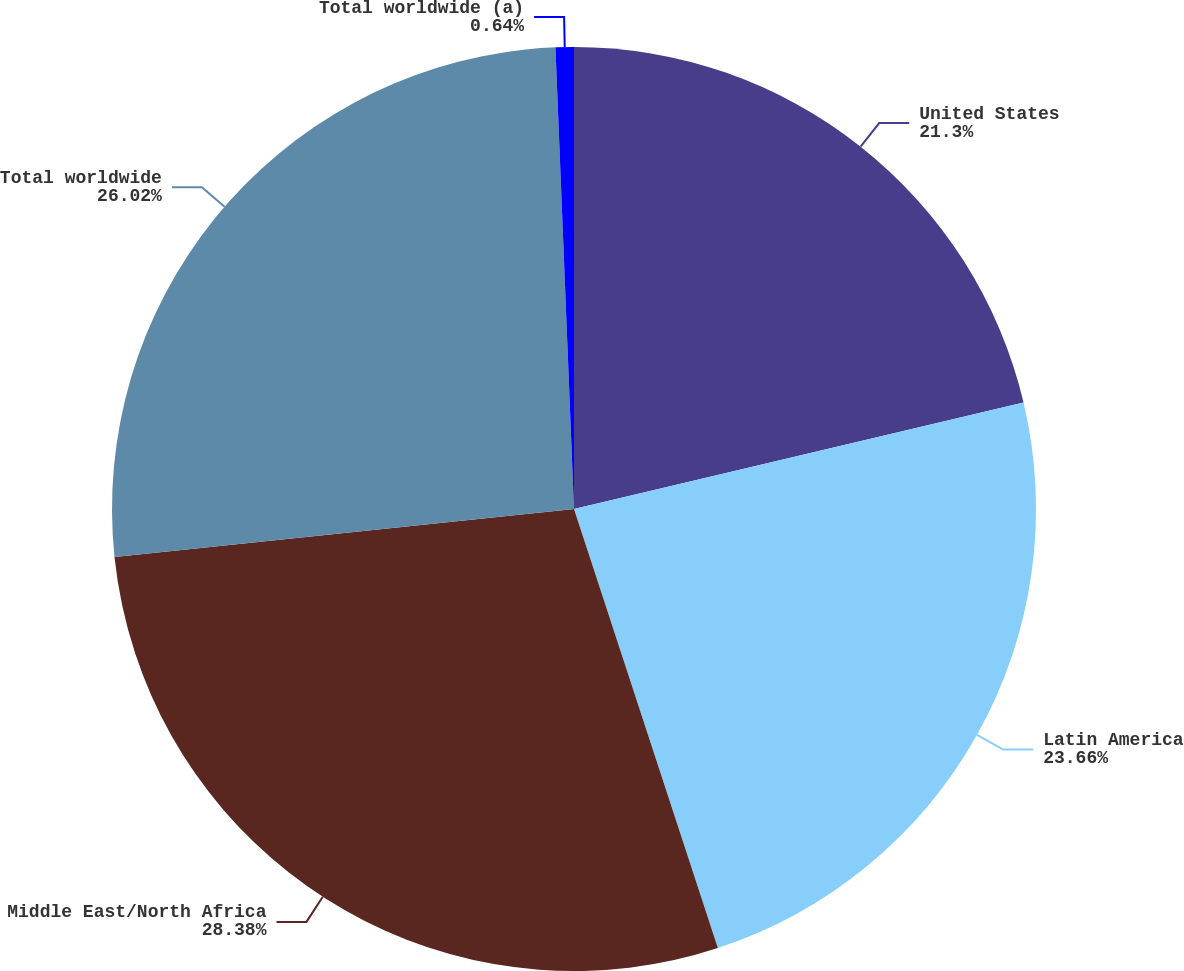Convert chart. <chart><loc_0><loc_0><loc_500><loc_500><pie_chart><fcel>United States<fcel>Latin America<fcel>Middle East/North Africa<fcel>Total worldwide<fcel>Total worldwide (a)<nl><fcel>21.3%<fcel>23.66%<fcel>28.38%<fcel>26.02%<fcel>0.64%<nl></chart> 